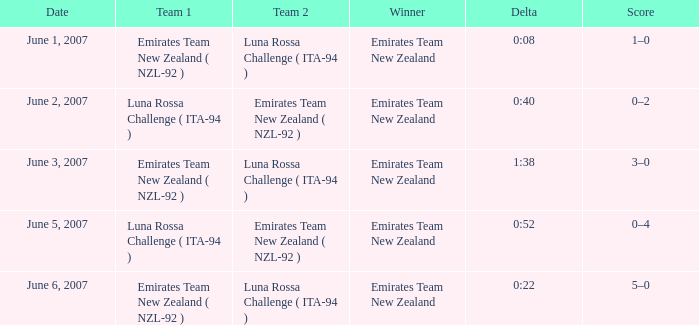On what Date is Delta 0:40? June 2, 2007. 